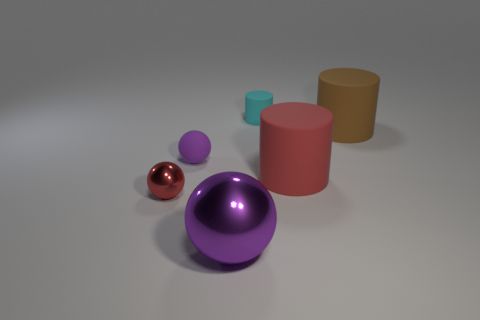What color is the tiny rubber thing in front of the cyan rubber thing?
Make the answer very short. Purple. Is the material of the thing that is in front of the tiny metal ball the same as the small red thing?
Provide a succinct answer. Yes. What number of large objects are both behind the large shiny ball and in front of the large brown object?
Make the answer very short. 1. There is a big rubber object right of the big cylinder in front of the large rubber thing that is behind the tiny purple ball; what color is it?
Your answer should be compact. Brown. What number of other things are the same shape as the big metal thing?
Your answer should be compact. 2. There is a rubber cylinder behind the large brown rubber cylinder; is there a large shiny sphere that is behind it?
Your answer should be very brief. No. What number of matte things are either small red balls or gray spheres?
Your response must be concise. 0. What is the small object that is to the left of the cyan cylinder and to the right of the red sphere made of?
Ensure brevity in your answer.  Rubber. Are there any purple objects that are in front of the red thing that is to the right of the big object in front of the tiny red shiny object?
Provide a succinct answer. Yes. What shape is the thing that is made of the same material as the large ball?
Offer a terse response. Sphere. 